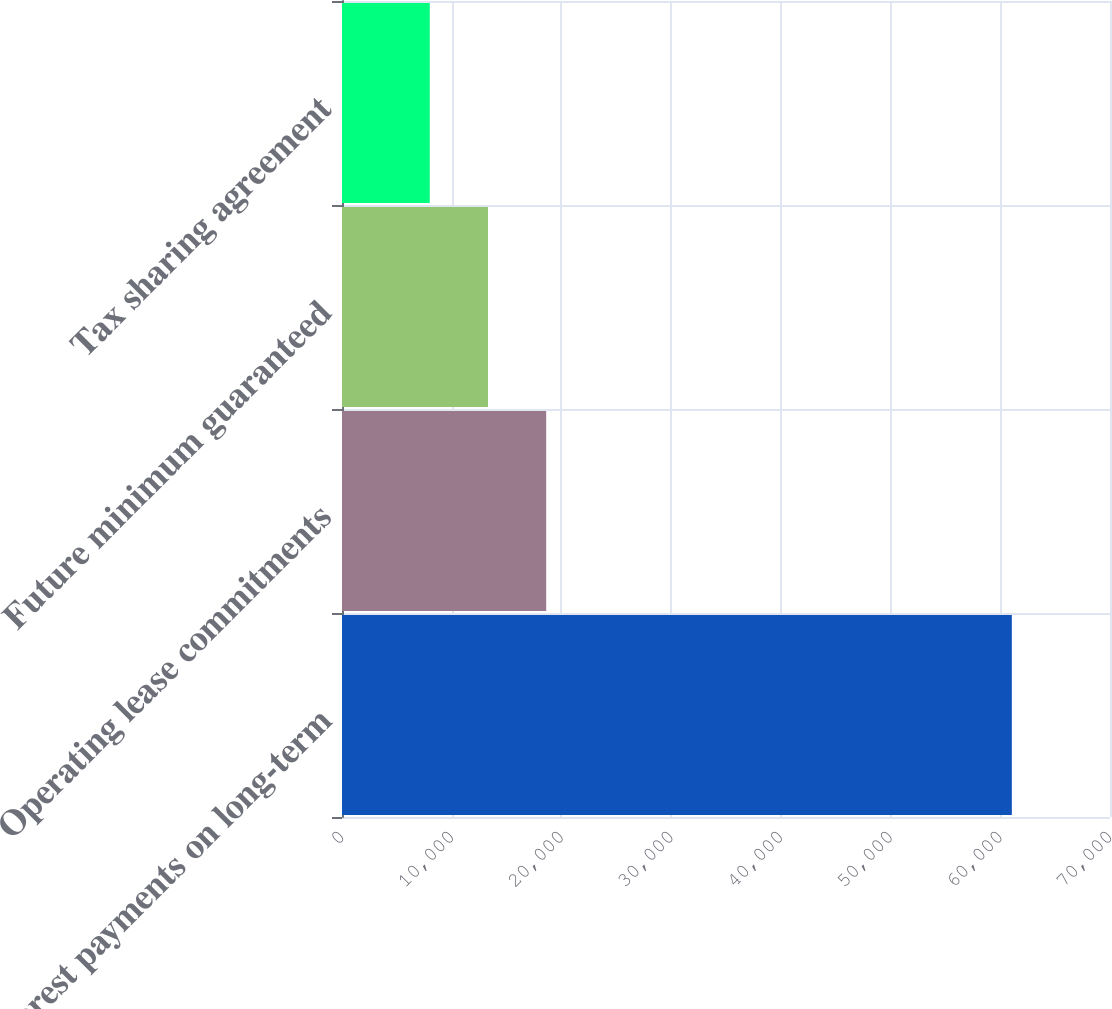Convert chart. <chart><loc_0><loc_0><loc_500><loc_500><bar_chart><fcel>Interest payments on long-term<fcel>Operating lease commitments<fcel>Future minimum guaranteed<fcel>Tax sharing agreement<nl><fcel>61053<fcel>18610.6<fcel>13305.3<fcel>8000<nl></chart> 